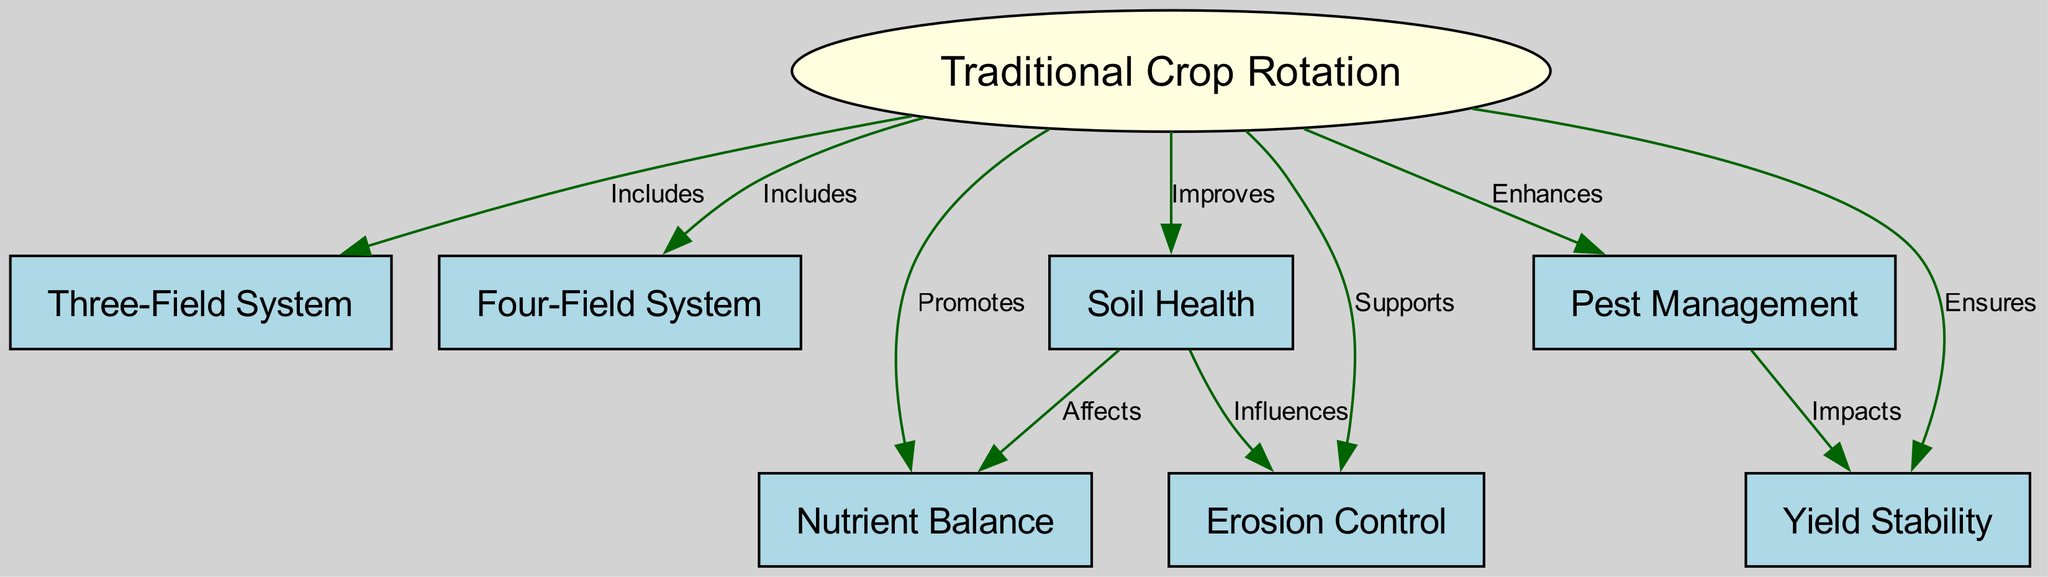What is the central concept of the diagram? The central concept is represented by node 1, which is labeled "Traditional Crop Rotation." This can be identified by its positioning and the shape (ellipse) that distinguishes it from other nodes.
Answer: Traditional Crop Rotation How many nodes are there in the diagram? By counting each unique entry in the nodes section, we find that there are eight nodes in total: Traditional Crop Rotation, Three-Field System, Four-Field System, Soil Health, Pest Management, Nutrient Balance, Erosion Control, and Yield Stability.
Answer: 8 What relationship does the "Three-Field System" have with "Traditional Crop Rotation"? The relationship is indicated by an edge that states "Includes," which is found in the edges section tying node 2 (Three-Field System) to node 1 (Traditional Crop Rotation).
Answer: Includes Which node directly impacts "Yield Stability"? This is determined by tracing the edges from the relevant nodes; node 5 (Pest Management) has an edge leading to node 8 (Yield Stability) labeled "Impacts." Thus, Pest Management directly influences Yield Stability.
Answer: Pest Management How do "Soil Health" and "Nutrient Balance" relate to each other? By examining the edges, we see that "Soil Health" (node 4) affects "Nutrient Balance" (node 6), implying that the health of the soil is linked to the nutrient levels within it.
Answer: Affects What does the "Four-Field System" contribute to "Soil Health"? The diagram indicates that "Traditional Crop Rotation" (node 1) includes "Four-Field System" (node 3) and that it improves "Soil Health" (node 4). Thus, the contribution of the Four-Field System is improvement in Soil Health through its inclusion under Traditional Crop Rotation.
Answer: Improves Which method supports "Erosion Control"? According to the diagram, "Traditional Crop Rotation" (node 1) supports "Erosion Control" (node 7). Thus, Traditional Crop Rotation plays a role in helping control erosion.
Answer: Supports How many benefits of "Soil Health" are shown in the diagram? By looking at how many edges lead from "Soil Health" (node 4), we find two relationships: "Affects" (Nutrient Balance) and "Influences" (Erosion Control). Therefore, there are two benefits linked to Soil Health.
Answer: 2 